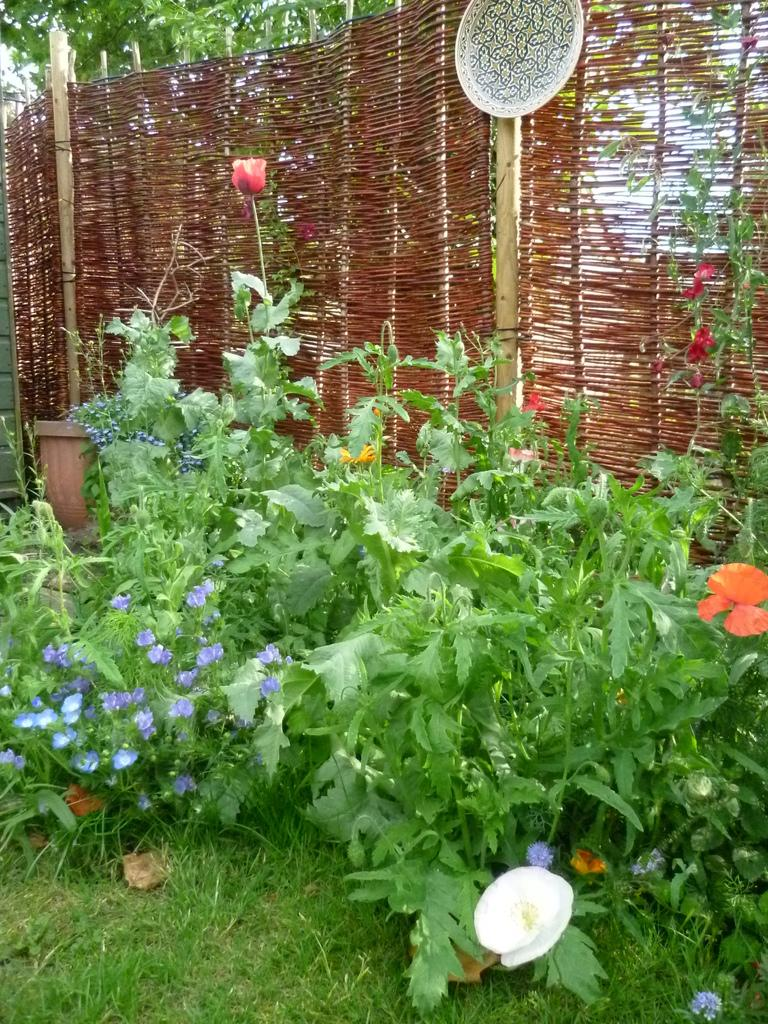What type of structure can be seen in the image? There is a fence in the image. What else is present in the image besides the fence? There are poles, a designed object, a tree, plants, flowers, and a pot visible in the image. What is the color of the grass in the image? Green grass is visible in the image. What type of cheese is being cut with a knife in the image? There is no cheese or knife present in the image. Is there a veil covering any part of the image? No, there is no veil present in the image. 